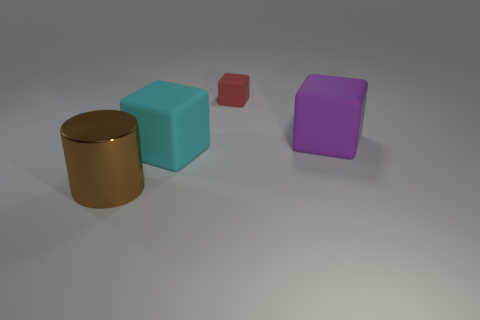Is there anything else that has the same material as the cyan thing?
Your answer should be very brief. Yes. Are there any big cyan things that have the same material as the small red cube?
Your response must be concise. Yes. There is a big block in front of the big purple matte thing; what is it made of?
Offer a very short reply. Rubber. What is the color of the block that is the same size as the purple matte object?
Give a very brief answer. Cyan. What number of other objects are the same shape as the small matte thing?
Ensure brevity in your answer.  2. What size is the cube behind the big purple cube?
Make the answer very short. Small. What number of large matte things are right of the big block left of the tiny matte thing?
Your answer should be compact. 1. How many other things are there of the same size as the cyan matte block?
Ensure brevity in your answer.  2. There is a object that is behind the large purple matte object; does it have the same shape as the large metallic thing?
Provide a succinct answer. No. How many things are both in front of the large cyan thing and behind the large brown metallic cylinder?
Your answer should be compact. 0. 